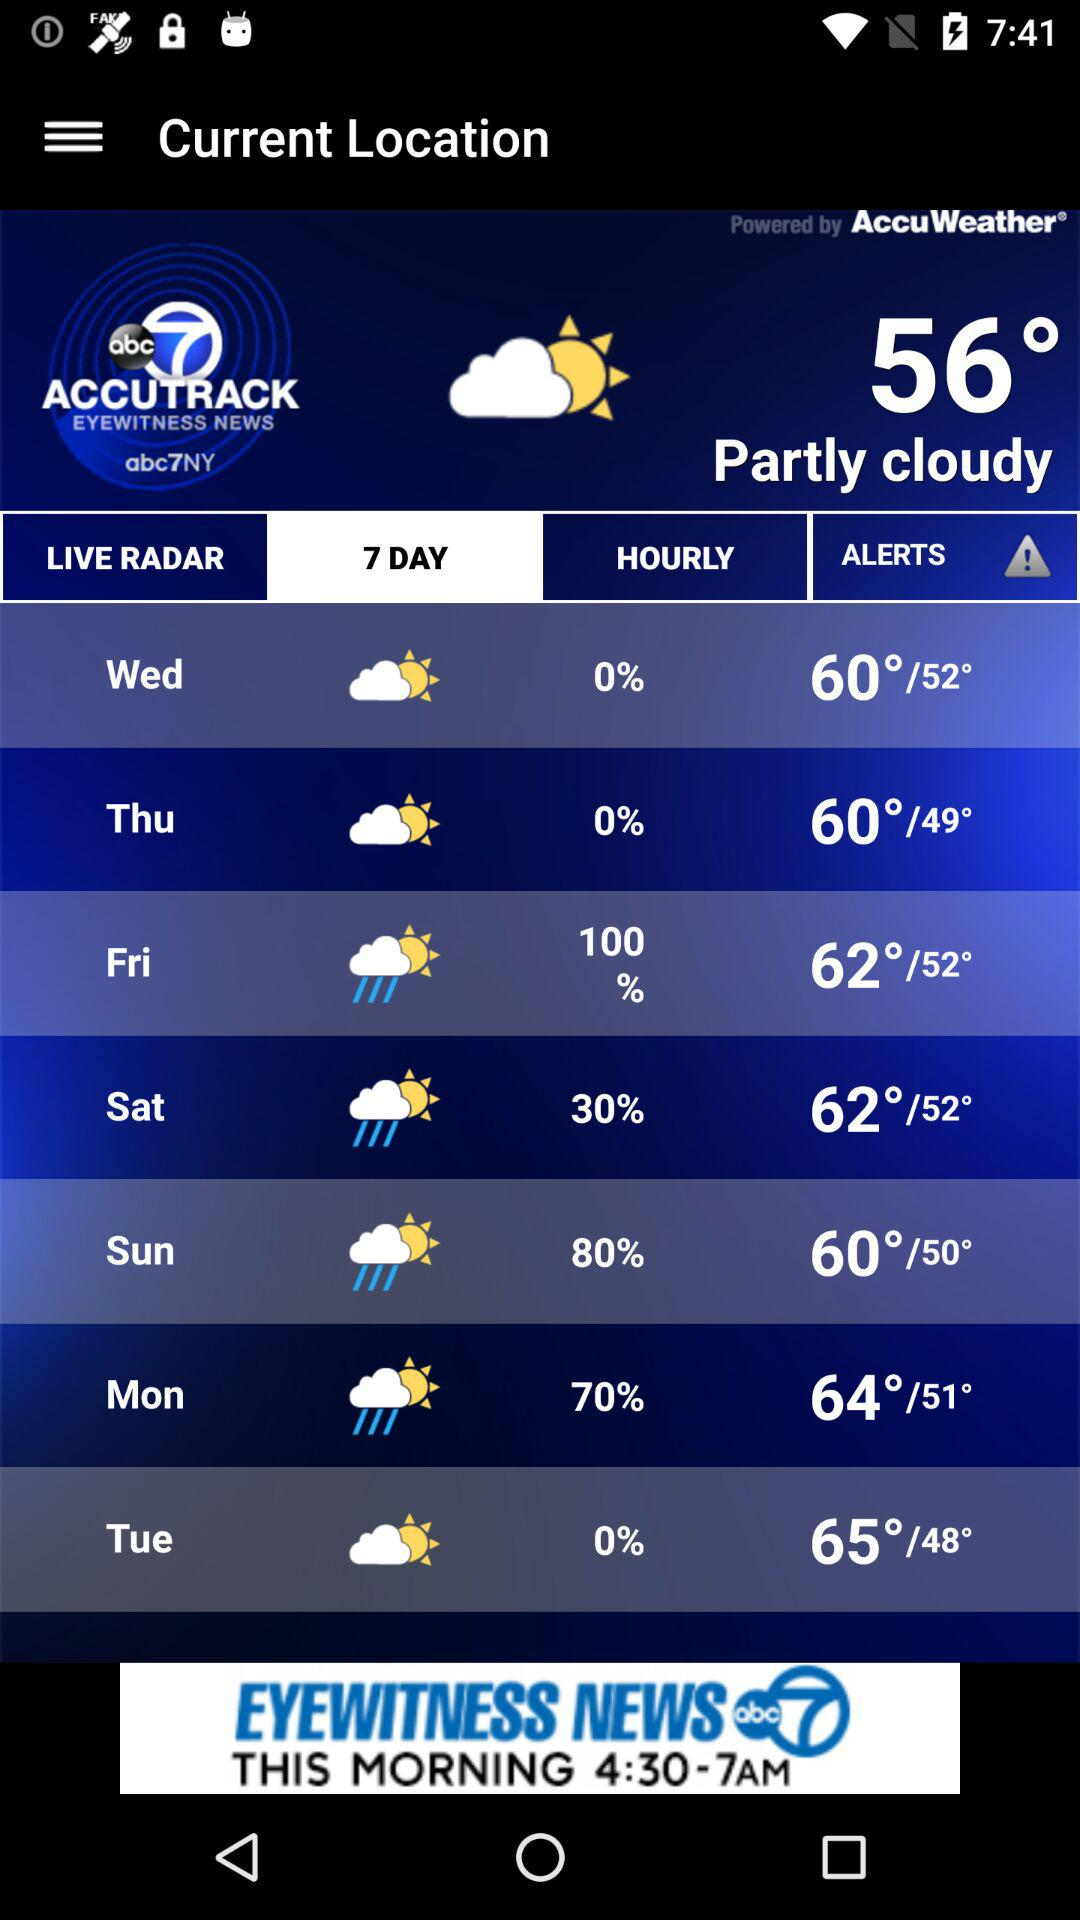What is the temperature for Saturday?
Answer the question using a single word or phrase. 62°/52° 